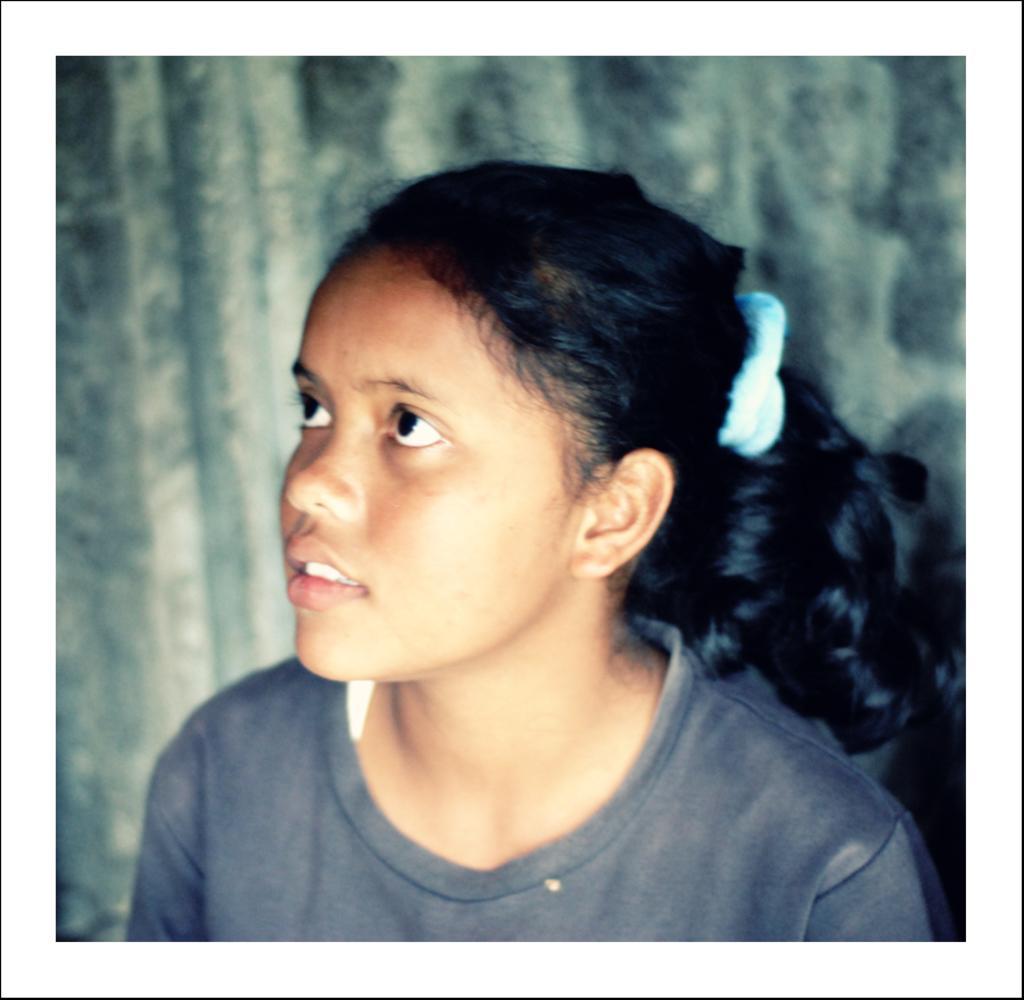How would you summarize this image in a sentence or two? There is a girl she is wearing a gray shirt and a ponytail, she is looking to her left side upwards,the background of the girl is blur. 